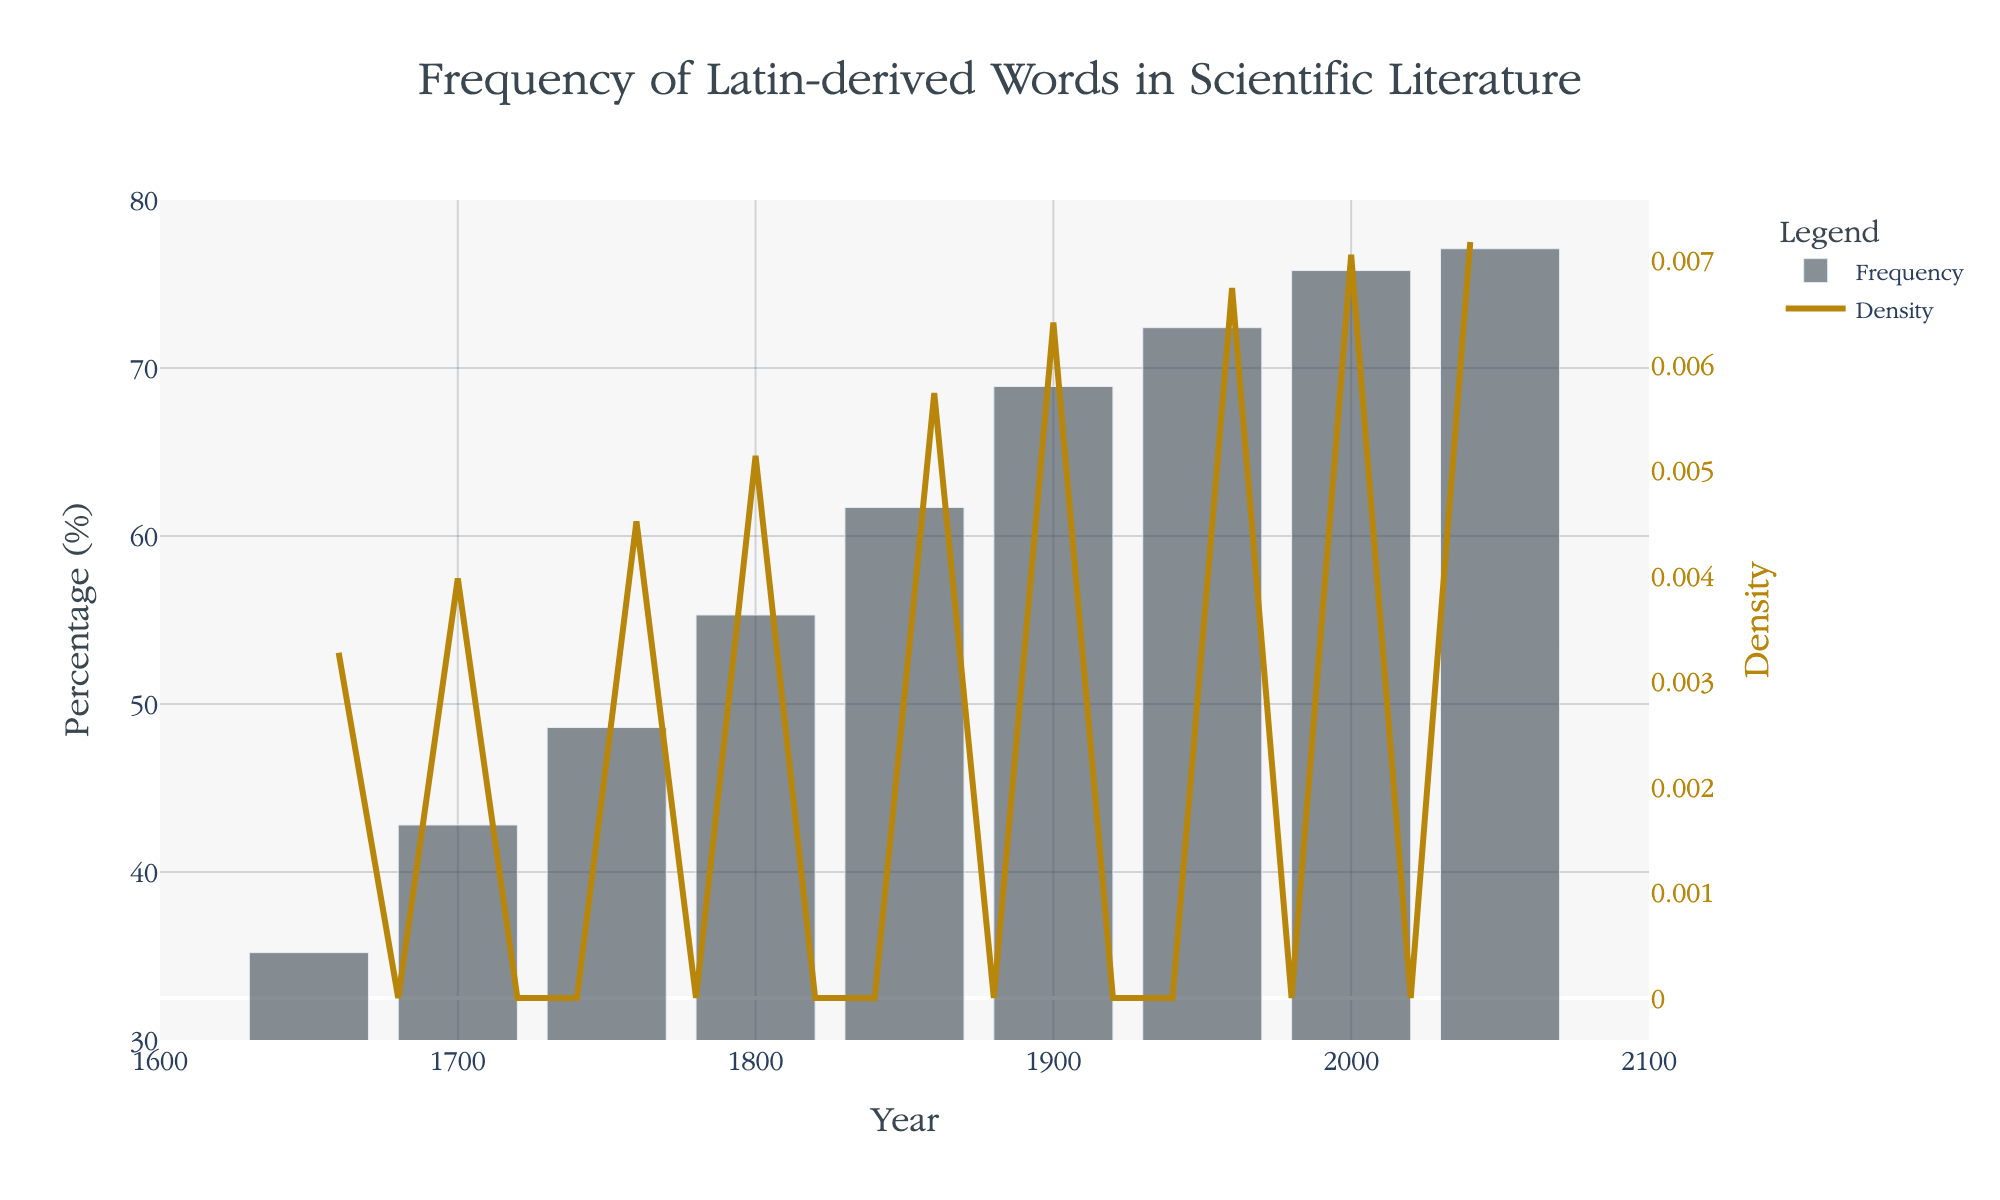What is the title of the figure? The title is found at the top of the figure. It uses a larger and differently colored font compared to the axis or legend labels, making it distinct and easy to find.
Answer: Frequency of Latin-derived Words in Scientific Literature What is the range of years displayed on the x-axis? The x-axis range can be located by observing the beginning and the end values on the x-axis near the bottom horizontal line of the figure.
Answer: 1600 to 2100 Which year has the highest percentage of Latin-derived words? Look at the bar heights, which represent the percentage values for each year. The tallest bar indicates the highest percentage.
Answer: 2050 What is the lowest percentage of Latin-derived words shown in the figure and in which year? Identify the shortest bar to determine the lowest percentage and read the corresponding year from the x-axis below it.
Answer: 35.2% in 1650 How does the percentage of Latin-derived words change from 1650 to 2050? Compare the height of the bar in 1650 with that in 2050 to find out how the percentage changes over this period.
Answer: Increases from 35.2% to 77.1% What is the overall trend observed in the frequency of Latin-derived words from 1650 to 2050? By looking at how the bar heights change over the years, deduce whether they generally increase, decrease, or remain stable over time.
Answer: Increasing What year marks the midpoint of the range displayed, and what is the approximate percentage of Latin-derived words at this midpoint? The midpoint year is the average of the start and end years (1650 and 2050). Determine the percentage corresponding to this midpoint year by finding the bar height.
Answer: Midpoint is 1850, Percentage is 61.7% How does the density (KDE) curve behave across the range of years displayed? Observe the secondary y-axis, which represents density, and describe the shape and trend of the KDE curve.
Answer: Shows peaks and variations indicating changes in data concentration Are there any noticeable peaks or troughs in the density (KDE) curve? If so, around which years do they occur? Examine the KDE curve to spot any significant rises (peaks) or drops (troughs) and identify the years corresponding to these features.
Answer: Peak around 2000 How would you describe the relationship between the histogram bars and the KDE curve? Analyze how the KDE curve aligns with the histogram bars to infer the relationship between percentage frequencies and data density.
Answer: KDE smoothens and highlights trends of histogram bars 